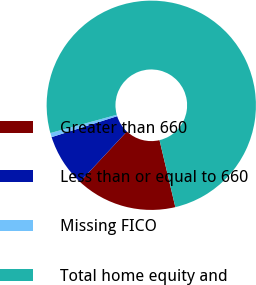<chart> <loc_0><loc_0><loc_500><loc_500><pie_chart><fcel>Greater than 660<fcel>Less than or equal to 660<fcel>Missing FICO<fcel>Total home equity and<nl><fcel>15.63%<fcel>8.14%<fcel>0.65%<fcel>75.58%<nl></chart> 